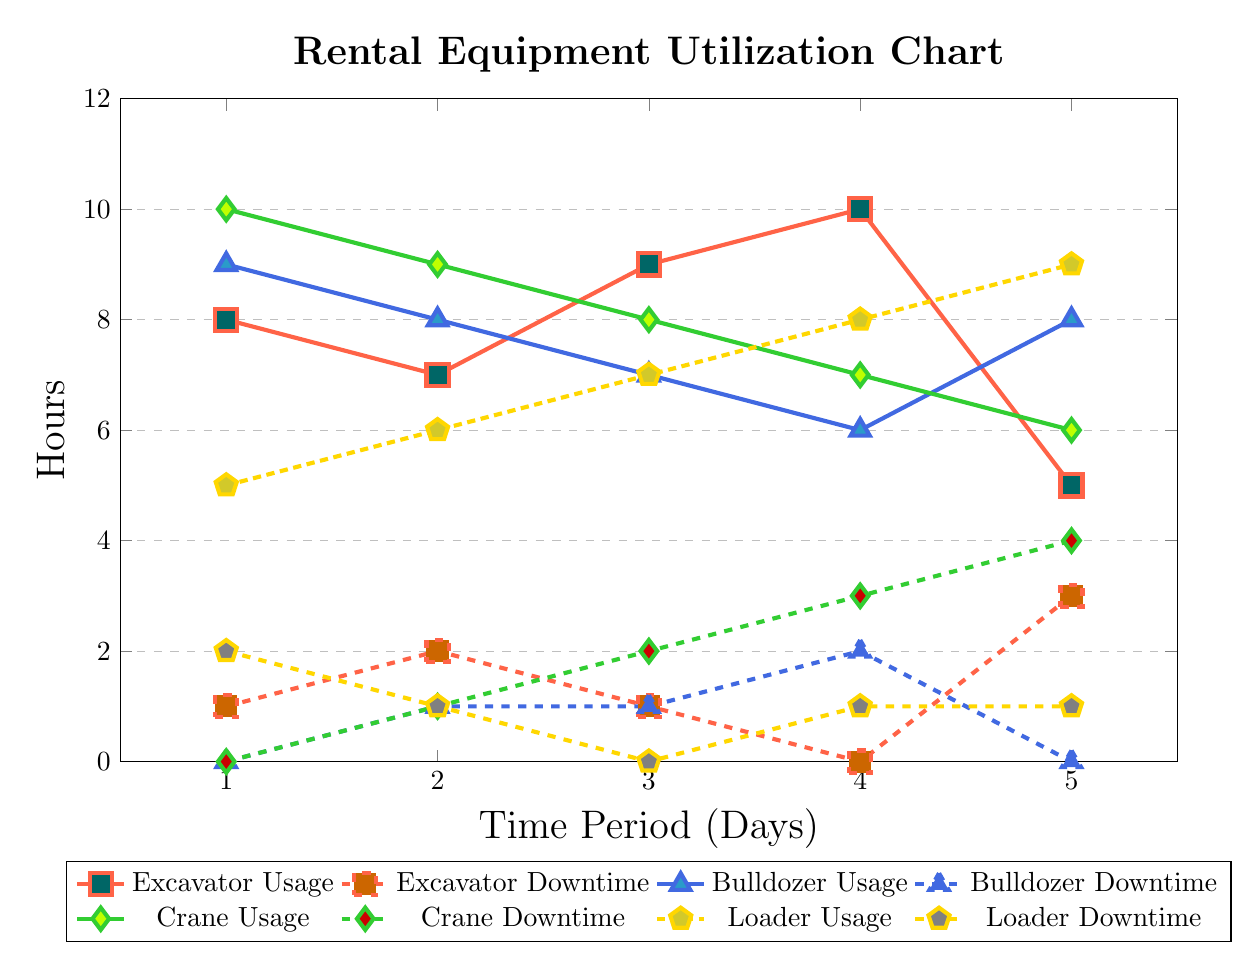What is the usage hour of the excavator on day 3? The usage hour for the excavator on day 3 is located on the excavator usage line. By checking the y-coordinate on day 3, we see that it corresponds to 9 hours.
Answer: 9 hours What is the downtime of the bulldozer on day 2? The downtime for the bulldozer on day 2 is indicated on the bulldozer downtime line at day 2. The y-coordinate shows 1 hour of downtime.
Answer: 1 hour Which equipment has the highest usage on day 1? Looking at the usage lines for all equipment on day 1, the crane shows the highest y-coordinate at 10 hours. This is more than any other equipment's usage on that day.
Answer: Crane What is the total downtime for the loader over the 5 days? To find the total downtime for the loader, we look at the loader downtime values from each day: 2, 1, 0, 1, and 1. Adding these values gives 2+1+0+1+1 = 5 hours of total downtime.
Answer: 5 hours On which day does the excavator have the least usage? By observing the excavator usage line, the least usage is found on day 5, where the y-coordinate is at 5 hours, the lowest among all days.
Answer: Day 5 What color represents crane usage in the chart? The crane usage is represented by the color green, specifically the color defined as craneColor in the code, which corresponds to the y-values in the chart.
Answer: Green How many total hours of usage does the bulldozer have across the 5 days? The bulldozer usage hours for each day are: 9, 8, 7, 6, and 8. Adding these together gives 9+8+7+6+8 = 38 hours of total usage.
Answer: 38 hours Which equipment has more downtime on average: the loader or the excavator? We calculate the average downtime for both: loader has downtime values 2, 1, 0, 1, and 1 (average = 1). The excavator has values 1, 2, 1, 0, and 3 (average = 1.4). Since 1 < 1.4, the loader has less average downtime.
Answer: Loader What is the maximum number of usage hours for any equipment on day 4? By reviewing the usage hours for all equipment on day 4, the maximum usage is seen in the excavator, which is at 10 hours.
Answer: 10 hours 